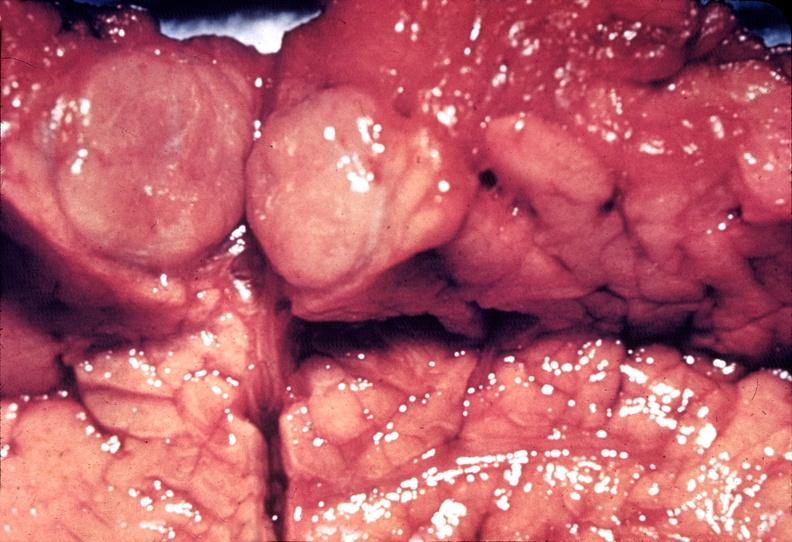does size show islet cell carcinoma?
Answer the question using a single word or phrase. No 